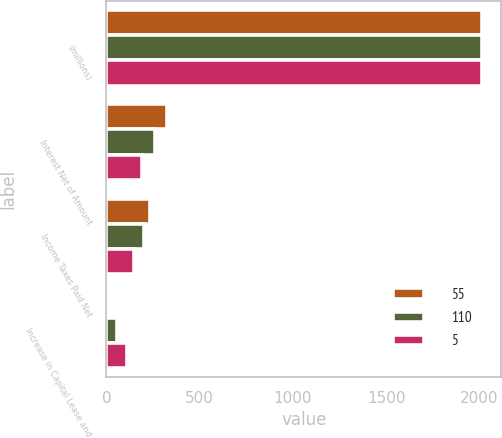<chart> <loc_0><loc_0><loc_500><loc_500><stacked_bar_chart><ecel><fcel>(millions)<fcel>Interest Net of Amount<fcel>Income Taxes Paid Net<fcel>Increase in Capital Lease and<nl><fcel>55<fcel>2016<fcel>327<fcel>236<fcel>5<nl><fcel>110<fcel>2015<fcel>260<fcel>202<fcel>55<nl><fcel>5<fcel>2014<fcel>189<fcel>150<fcel>110<nl></chart> 